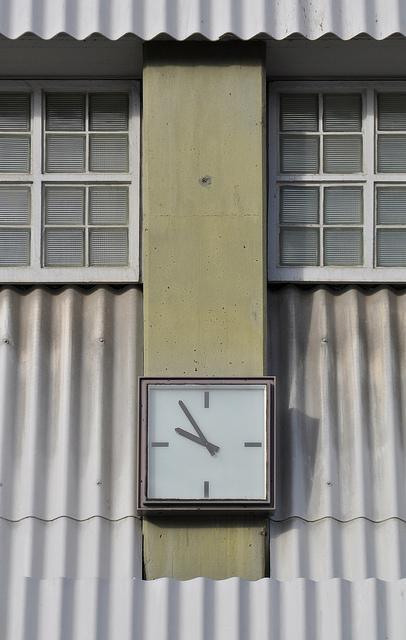Is it morning or afternoon?
Keep it brief. Morning. Is this inside or outside?
Keep it brief. Outside. Is this an old clock?
Answer briefly. Yes. 